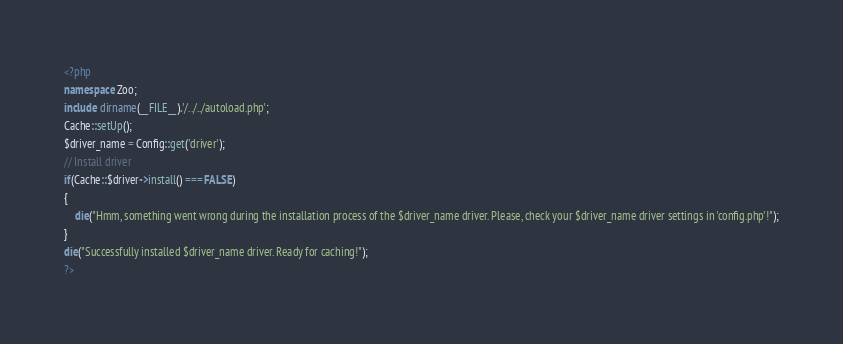<code> <loc_0><loc_0><loc_500><loc_500><_PHP_><?php
namespace Zoo;
include dirname(__FILE__).'/../../autoload.php';
Cache::setUp();
$driver_name = Config::get('driver');
// Install driver
if(Cache::$driver->install() === FALSE)
{
	die("Hmm, something went wrong during the installation process of the $driver_name driver. Please, check your $driver_name driver settings in 'config.php'!");
}
die("Successfully installed $driver_name driver. Ready for caching!");
?></code> 